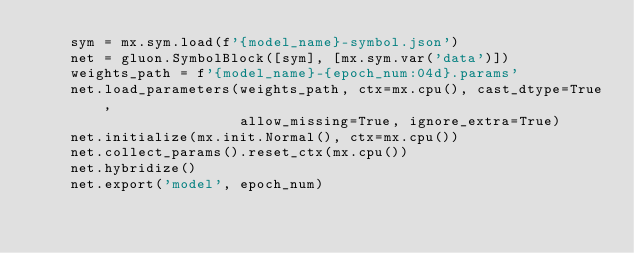<code> <loc_0><loc_0><loc_500><loc_500><_Python_>    sym = mx.sym.load(f'{model_name}-symbol.json')
    net = gluon.SymbolBlock([sym], [mx.sym.var('data')])
    weights_path = f'{model_name}-{epoch_num:04d}.params'
    net.load_parameters(weights_path, ctx=mx.cpu(), cast_dtype=True,
                        allow_missing=True, ignore_extra=True) 
    net.initialize(mx.init.Normal(), ctx=mx.cpu()) 
    net.collect_params().reset_ctx(mx.cpu())
    net.hybridize() 
    net.export('model', epoch_num) 
</code> 